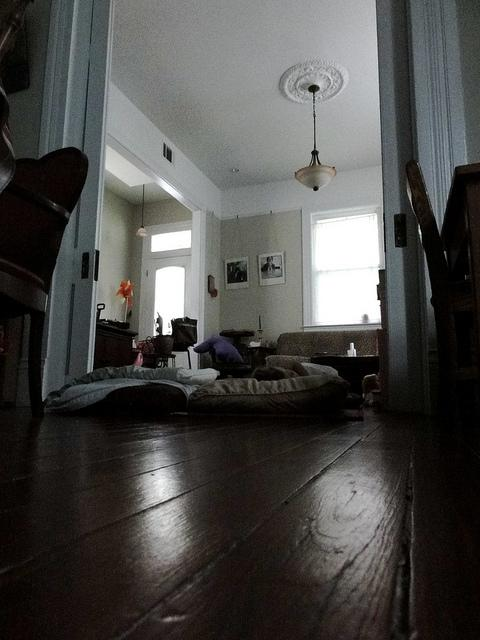What is the highest object in the room?

Choices:
A) couch
B) hanging light
C) dog bed
D) table hanging light 